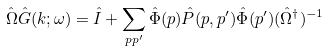<formula> <loc_0><loc_0><loc_500><loc_500>\hat { \Omega } \hat { G } ( k ; \omega ) = \hat { I } + \sum _ { p p ^ { \prime } } \hat { \Phi } ( p ) \hat { P } ( p , p ^ { \prime } ) \hat { \Phi } ( p ^ { \prime } ) ( \hat { \Omega } ^ { \dagger } ) ^ { - 1 }</formula> 